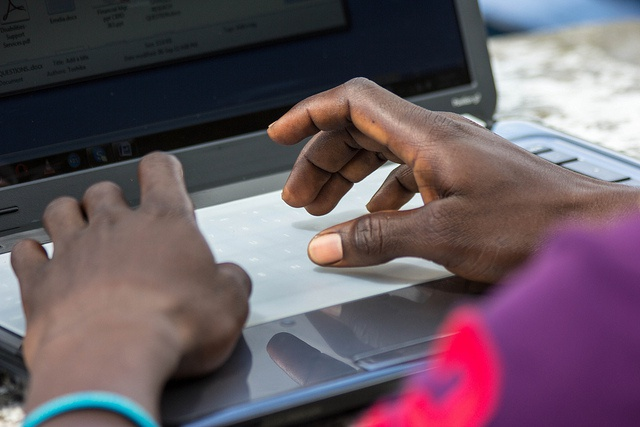Describe the objects in this image and their specific colors. I can see laptop in black, gray, and lightgray tones, people in black, gray, purple, and maroon tones, and keyboard in black, lightgray, darkgray, and gray tones in this image. 